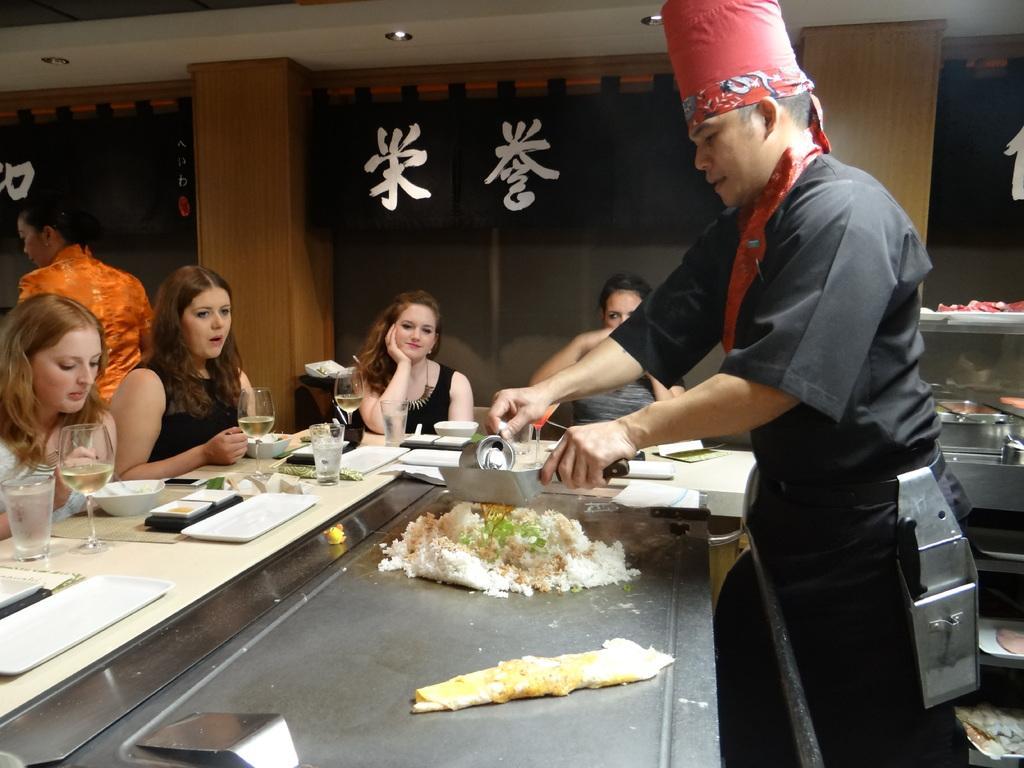Please provide a concise description of this image. In this picture I can see a man who is standing and I see that he is wearing black color dress and a hat on his head and he is holding utensils in his hands. I can also see the silver color thing on which there is food. In the background I can see 4 women who are sitting and in front of them I can see the bowls, glasses, plates and other few things. In the background I can see the pillars and black color clothes on which there is something written and on the top of this picture I can see the lights. 